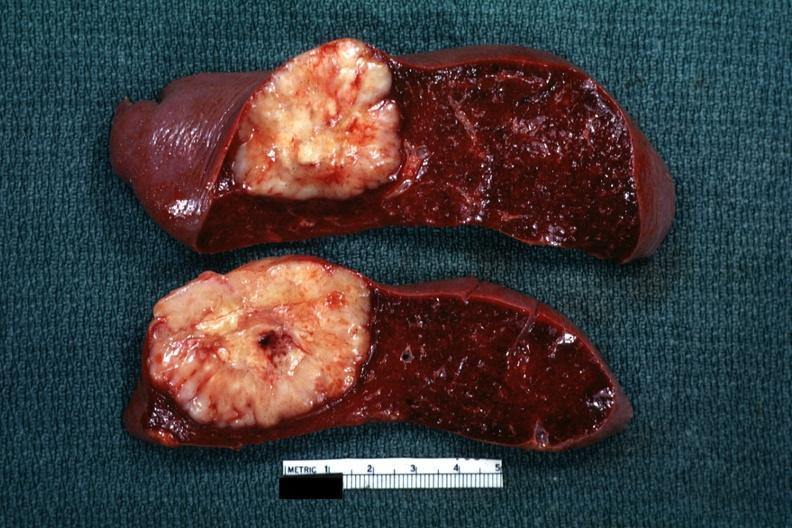where is this part in?
Answer the question using a single word or phrase. Spleen 